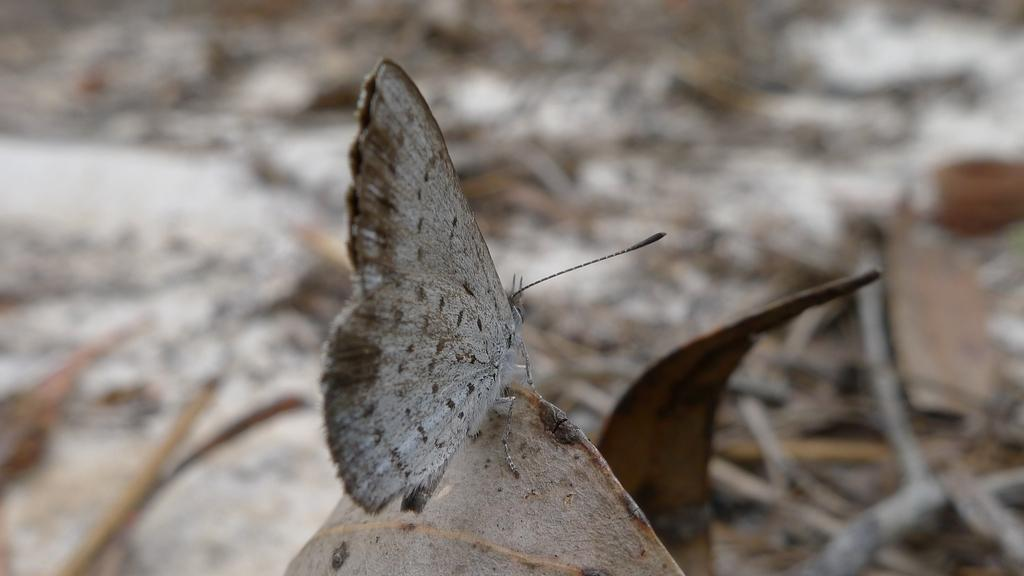What is the main subject of the image? There is a butterfly in the image. Where is the butterfly located in the image? The butterfly is standing on a leaf. Can you describe the background of the image? The background of the image is slightly blurry. What type of cream can be seen dripping from the mailbox in the image? There is no mailbox or cream present in the image; it features a butterfly standing on a leaf. What sound does the bell make in the image? There is no bell present in the image. 